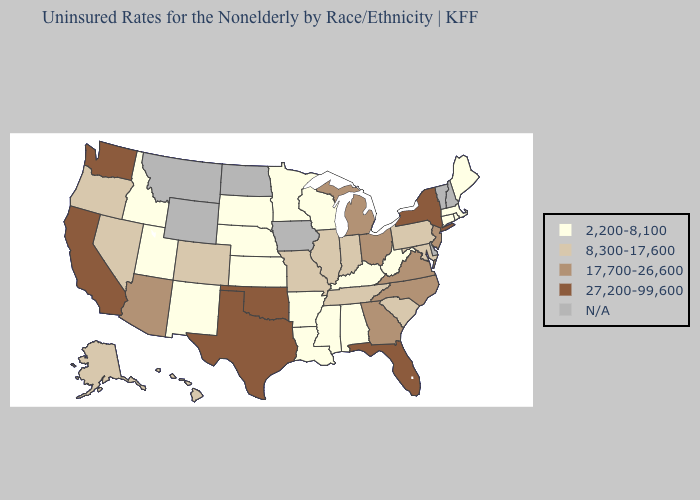Does Nebraska have the highest value in the USA?
Answer briefly. No. Which states have the highest value in the USA?
Concise answer only. California, Florida, New York, Oklahoma, Texas, Washington. What is the highest value in the USA?
Answer briefly. 27,200-99,600. What is the highest value in the MidWest ?
Be succinct. 17,700-26,600. Name the states that have a value in the range 17,700-26,600?
Keep it brief. Arizona, Georgia, Michigan, New Jersey, North Carolina, Ohio, Virginia. Which states hav the highest value in the South?
Keep it brief. Florida, Oklahoma, Texas. Which states hav the highest value in the MidWest?
Keep it brief. Michigan, Ohio. Which states have the lowest value in the USA?
Write a very short answer. Alabama, Arkansas, Connecticut, Idaho, Kansas, Kentucky, Louisiana, Maine, Massachusetts, Minnesota, Mississippi, Nebraska, New Mexico, Rhode Island, South Dakota, Utah, West Virginia, Wisconsin. Is the legend a continuous bar?
Be succinct. No. Does Pennsylvania have the highest value in the Northeast?
Answer briefly. No. What is the value of Texas?
Write a very short answer. 27,200-99,600. What is the value of Michigan?
Keep it brief. 17,700-26,600. Does the map have missing data?
Keep it brief. Yes. 